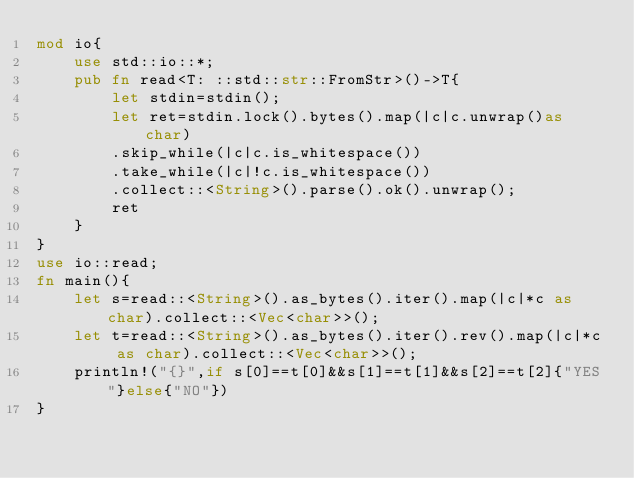Convert code to text. <code><loc_0><loc_0><loc_500><loc_500><_Rust_>mod io{
    use std::io::*;
    pub fn read<T: ::std::str::FromStr>()->T{
        let stdin=stdin();
        let ret=stdin.lock().bytes().map(|c|c.unwrap()as char)
        .skip_while(|c|c.is_whitespace())
        .take_while(|c|!c.is_whitespace())
        .collect::<String>().parse().ok().unwrap();
        ret
    }
}
use io::read;
fn main(){
    let s=read::<String>().as_bytes().iter().map(|c|*c as char).collect::<Vec<char>>();
    let t=read::<String>().as_bytes().iter().rev().map(|c|*c as char).collect::<Vec<char>>();
    println!("{}",if s[0]==t[0]&&s[1]==t[1]&&s[2]==t[2]{"YES"}else{"NO"})
}</code> 